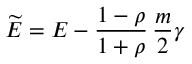<formula> <loc_0><loc_0><loc_500><loc_500>\widetilde { E } = E - \frac { 1 - \rho } { 1 + \rho } \, \frac { m } { 2 } \gamma</formula> 